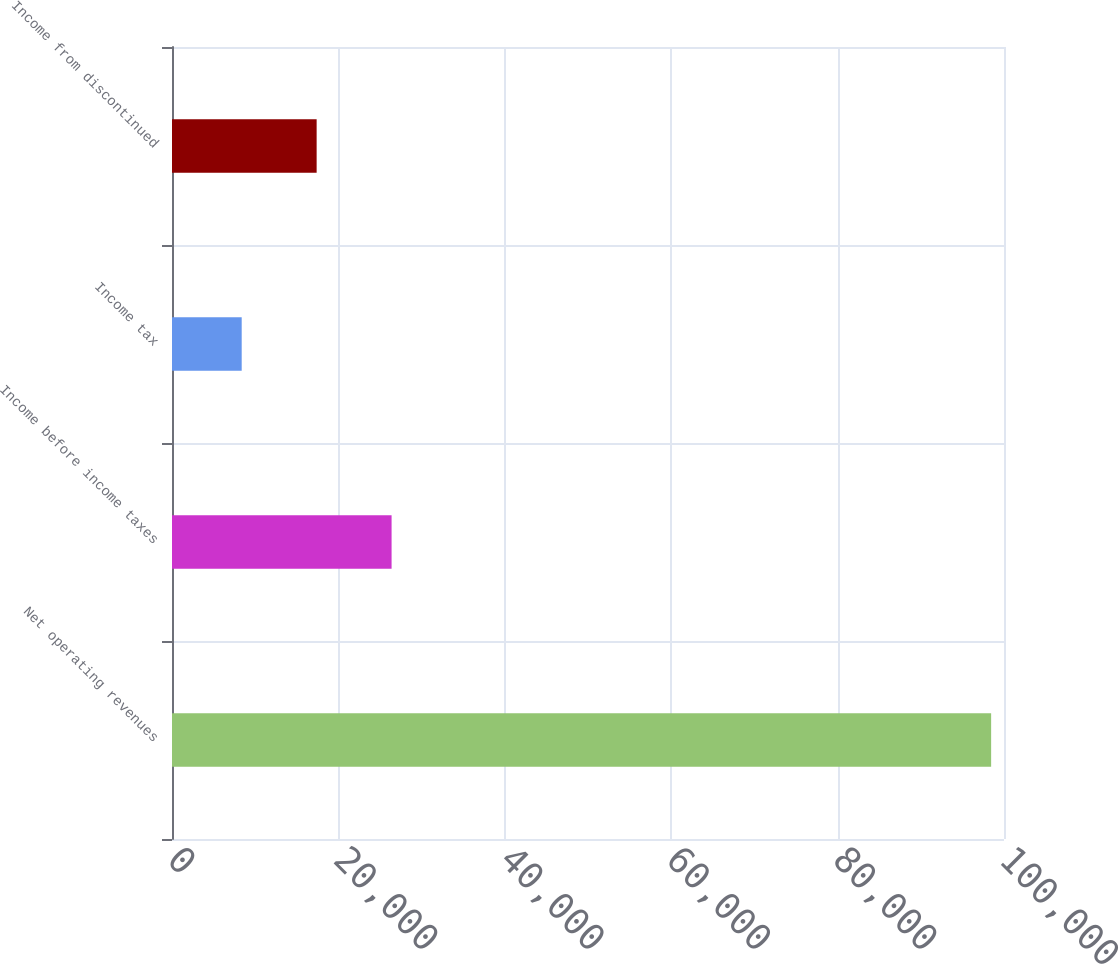Convert chart to OTSL. <chart><loc_0><loc_0><loc_500><loc_500><bar_chart><fcel>Net operating revenues<fcel>Income before income taxes<fcel>Income tax<fcel>Income from discontinued<nl><fcel>98454<fcel>26392.4<fcel>8377<fcel>17384.7<nl></chart> 